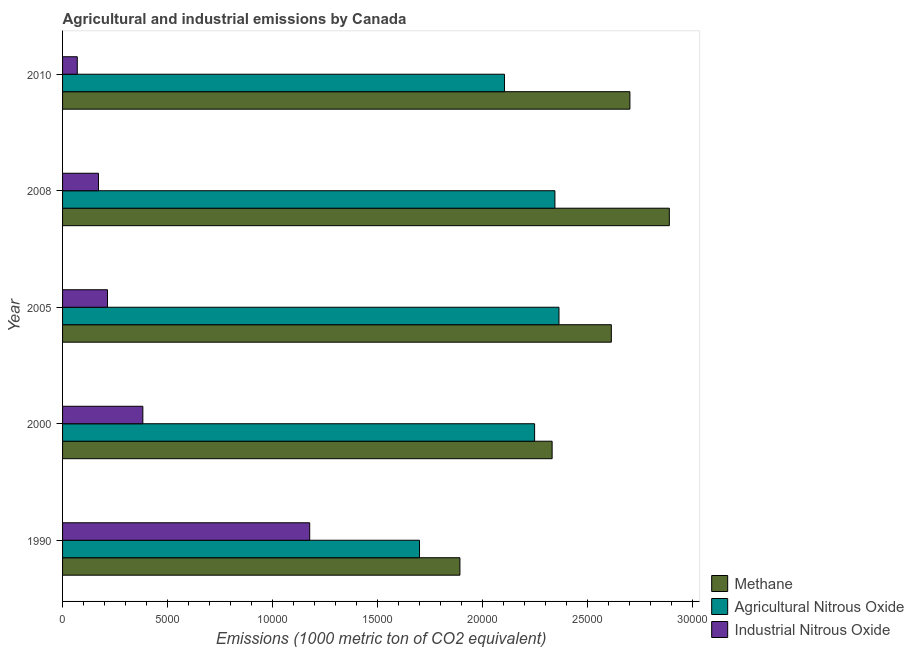How many groups of bars are there?
Your response must be concise. 5. Are the number of bars on each tick of the Y-axis equal?
Your response must be concise. Yes. How many bars are there on the 1st tick from the top?
Your response must be concise. 3. How many bars are there on the 1st tick from the bottom?
Keep it short and to the point. 3. What is the label of the 4th group of bars from the top?
Give a very brief answer. 2000. In how many cases, is the number of bars for a given year not equal to the number of legend labels?
Provide a short and direct response. 0. What is the amount of methane emissions in 2000?
Your answer should be very brief. 2.33e+04. Across all years, what is the maximum amount of industrial nitrous oxide emissions?
Offer a terse response. 1.18e+04. Across all years, what is the minimum amount of methane emissions?
Your answer should be very brief. 1.89e+04. In which year was the amount of industrial nitrous oxide emissions minimum?
Ensure brevity in your answer.  2010. What is the total amount of methane emissions in the graph?
Your response must be concise. 1.24e+05. What is the difference between the amount of agricultural nitrous oxide emissions in 2000 and that in 2010?
Keep it short and to the point. 1435.7. What is the difference between the amount of methane emissions in 2000 and the amount of agricultural nitrous oxide emissions in 1990?
Keep it short and to the point. 6315.8. What is the average amount of industrial nitrous oxide emissions per year?
Keep it short and to the point. 4028.68. In the year 2008, what is the difference between the amount of industrial nitrous oxide emissions and amount of methane emissions?
Make the answer very short. -2.72e+04. What is the ratio of the amount of methane emissions in 2000 to that in 2010?
Ensure brevity in your answer.  0.86. Is the difference between the amount of industrial nitrous oxide emissions in 2000 and 2008 greater than the difference between the amount of methane emissions in 2000 and 2008?
Give a very brief answer. Yes. What is the difference between the highest and the second highest amount of industrial nitrous oxide emissions?
Your answer should be compact. 7946.7. What is the difference between the highest and the lowest amount of methane emissions?
Give a very brief answer. 9973.1. What does the 1st bar from the top in 2010 represents?
Offer a terse response. Industrial Nitrous Oxide. What does the 2nd bar from the bottom in 2010 represents?
Offer a terse response. Agricultural Nitrous Oxide. Is it the case that in every year, the sum of the amount of methane emissions and amount of agricultural nitrous oxide emissions is greater than the amount of industrial nitrous oxide emissions?
Give a very brief answer. Yes. How many years are there in the graph?
Provide a succinct answer. 5. What is the difference between two consecutive major ticks on the X-axis?
Your response must be concise. 5000. Are the values on the major ticks of X-axis written in scientific E-notation?
Keep it short and to the point. No. Where does the legend appear in the graph?
Your response must be concise. Bottom right. How many legend labels are there?
Provide a succinct answer. 3. How are the legend labels stacked?
Your response must be concise. Vertical. What is the title of the graph?
Your response must be concise. Agricultural and industrial emissions by Canada. Does "Nuclear sources" appear as one of the legend labels in the graph?
Keep it short and to the point. No. What is the label or title of the X-axis?
Offer a very short reply. Emissions (1000 metric ton of CO2 equivalent). What is the label or title of the Y-axis?
Provide a succinct answer. Year. What is the Emissions (1000 metric ton of CO2 equivalent) in Methane in 1990?
Make the answer very short. 1.89e+04. What is the Emissions (1000 metric ton of CO2 equivalent) of Agricultural Nitrous Oxide in 1990?
Your answer should be very brief. 1.70e+04. What is the Emissions (1000 metric ton of CO2 equivalent) of Industrial Nitrous Oxide in 1990?
Your answer should be very brief. 1.18e+04. What is the Emissions (1000 metric ton of CO2 equivalent) in Methane in 2000?
Give a very brief answer. 2.33e+04. What is the Emissions (1000 metric ton of CO2 equivalent) in Agricultural Nitrous Oxide in 2000?
Your answer should be very brief. 2.25e+04. What is the Emissions (1000 metric ton of CO2 equivalent) of Industrial Nitrous Oxide in 2000?
Your response must be concise. 3823.3. What is the Emissions (1000 metric ton of CO2 equivalent) in Methane in 2005?
Your answer should be very brief. 2.61e+04. What is the Emissions (1000 metric ton of CO2 equivalent) in Agricultural Nitrous Oxide in 2005?
Provide a succinct answer. 2.36e+04. What is the Emissions (1000 metric ton of CO2 equivalent) of Industrial Nitrous Oxide in 2005?
Ensure brevity in your answer.  2139.7. What is the Emissions (1000 metric ton of CO2 equivalent) of Methane in 2008?
Offer a very short reply. 2.89e+04. What is the Emissions (1000 metric ton of CO2 equivalent) in Agricultural Nitrous Oxide in 2008?
Provide a short and direct response. 2.34e+04. What is the Emissions (1000 metric ton of CO2 equivalent) of Industrial Nitrous Oxide in 2008?
Ensure brevity in your answer.  1709.6. What is the Emissions (1000 metric ton of CO2 equivalent) of Methane in 2010?
Ensure brevity in your answer.  2.70e+04. What is the Emissions (1000 metric ton of CO2 equivalent) of Agricultural Nitrous Oxide in 2010?
Provide a short and direct response. 2.10e+04. What is the Emissions (1000 metric ton of CO2 equivalent) in Industrial Nitrous Oxide in 2010?
Give a very brief answer. 700.8. Across all years, what is the maximum Emissions (1000 metric ton of CO2 equivalent) of Methane?
Your answer should be compact. 2.89e+04. Across all years, what is the maximum Emissions (1000 metric ton of CO2 equivalent) in Agricultural Nitrous Oxide?
Your response must be concise. 2.36e+04. Across all years, what is the maximum Emissions (1000 metric ton of CO2 equivalent) of Industrial Nitrous Oxide?
Provide a short and direct response. 1.18e+04. Across all years, what is the minimum Emissions (1000 metric ton of CO2 equivalent) of Methane?
Keep it short and to the point. 1.89e+04. Across all years, what is the minimum Emissions (1000 metric ton of CO2 equivalent) of Agricultural Nitrous Oxide?
Ensure brevity in your answer.  1.70e+04. Across all years, what is the minimum Emissions (1000 metric ton of CO2 equivalent) of Industrial Nitrous Oxide?
Your response must be concise. 700.8. What is the total Emissions (1000 metric ton of CO2 equivalent) in Methane in the graph?
Give a very brief answer. 1.24e+05. What is the total Emissions (1000 metric ton of CO2 equivalent) in Agricultural Nitrous Oxide in the graph?
Provide a short and direct response. 1.08e+05. What is the total Emissions (1000 metric ton of CO2 equivalent) in Industrial Nitrous Oxide in the graph?
Make the answer very short. 2.01e+04. What is the difference between the Emissions (1000 metric ton of CO2 equivalent) in Methane in 1990 and that in 2000?
Offer a terse response. -4391.7. What is the difference between the Emissions (1000 metric ton of CO2 equivalent) of Agricultural Nitrous Oxide in 1990 and that in 2000?
Your answer should be compact. -5481.4. What is the difference between the Emissions (1000 metric ton of CO2 equivalent) of Industrial Nitrous Oxide in 1990 and that in 2000?
Offer a very short reply. 7946.7. What is the difference between the Emissions (1000 metric ton of CO2 equivalent) of Methane in 1990 and that in 2005?
Ensure brevity in your answer.  -7210.8. What is the difference between the Emissions (1000 metric ton of CO2 equivalent) of Agricultural Nitrous Oxide in 1990 and that in 2005?
Keep it short and to the point. -6642.6. What is the difference between the Emissions (1000 metric ton of CO2 equivalent) in Industrial Nitrous Oxide in 1990 and that in 2005?
Ensure brevity in your answer.  9630.3. What is the difference between the Emissions (1000 metric ton of CO2 equivalent) of Methane in 1990 and that in 2008?
Your response must be concise. -9973.1. What is the difference between the Emissions (1000 metric ton of CO2 equivalent) of Agricultural Nitrous Oxide in 1990 and that in 2008?
Keep it short and to the point. -6448.9. What is the difference between the Emissions (1000 metric ton of CO2 equivalent) of Industrial Nitrous Oxide in 1990 and that in 2008?
Your answer should be very brief. 1.01e+04. What is the difference between the Emissions (1000 metric ton of CO2 equivalent) of Methane in 1990 and that in 2010?
Your answer should be very brief. -8095.8. What is the difference between the Emissions (1000 metric ton of CO2 equivalent) in Agricultural Nitrous Oxide in 1990 and that in 2010?
Ensure brevity in your answer.  -4045.7. What is the difference between the Emissions (1000 metric ton of CO2 equivalent) of Industrial Nitrous Oxide in 1990 and that in 2010?
Make the answer very short. 1.11e+04. What is the difference between the Emissions (1000 metric ton of CO2 equivalent) of Methane in 2000 and that in 2005?
Your answer should be very brief. -2819.1. What is the difference between the Emissions (1000 metric ton of CO2 equivalent) in Agricultural Nitrous Oxide in 2000 and that in 2005?
Keep it short and to the point. -1161.2. What is the difference between the Emissions (1000 metric ton of CO2 equivalent) of Industrial Nitrous Oxide in 2000 and that in 2005?
Give a very brief answer. 1683.6. What is the difference between the Emissions (1000 metric ton of CO2 equivalent) of Methane in 2000 and that in 2008?
Give a very brief answer. -5581.4. What is the difference between the Emissions (1000 metric ton of CO2 equivalent) of Agricultural Nitrous Oxide in 2000 and that in 2008?
Offer a very short reply. -967.5. What is the difference between the Emissions (1000 metric ton of CO2 equivalent) of Industrial Nitrous Oxide in 2000 and that in 2008?
Provide a short and direct response. 2113.7. What is the difference between the Emissions (1000 metric ton of CO2 equivalent) in Methane in 2000 and that in 2010?
Your response must be concise. -3704.1. What is the difference between the Emissions (1000 metric ton of CO2 equivalent) of Agricultural Nitrous Oxide in 2000 and that in 2010?
Make the answer very short. 1435.7. What is the difference between the Emissions (1000 metric ton of CO2 equivalent) in Industrial Nitrous Oxide in 2000 and that in 2010?
Make the answer very short. 3122.5. What is the difference between the Emissions (1000 metric ton of CO2 equivalent) in Methane in 2005 and that in 2008?
Your answer should be very brief. -2762.3. What is the difference between the Emissions (1000 metric ton of CO2 equivalent) of Agricultural Nitrous Oxide in 2005 and that in 2008?
Make the answer very short. 193.7. What is the difference between the Emissions (1000 metric ton of CO2 equivalent) of Industrial Nitrous Oxide in 2005 and that in 2008?
Provide a short and direct response. 430.1. What is the difference between the Emissions (1000 metric ton of CO2 equivalent) in Methane in 2005 and that in 2010?
Your answer should be very brief. -885. What is the difference between the Emissions (1000 metric ton of CO2 equivalent) of Agricultural Nitrous Oxide in 2005 and that in 2010?
Provide a succinct answer. 2596.9. What is the difference between the Emissions (1000 metric ton of CO2 equivalent) of Industrial Nitrous Oxide in 2005 and that in 2010?
Offer a very short reply. 1438.9. What is the difference between the Emissions (1000 metric ton of CO2 equivalent) of Methane in 2008 and that in 2010?
Offer a very short reply. 1877.3. What is the difference between the Emissions (1000 metric ton of CO2 equivalent) of Agricultural Nitrous Oxide in 2008 and that in 2010?
Ensure brevity in your answer.  2403.2. What is the difference between the Emissions (1000 metric ton of CO2 equivalent) in Industrial Nitrous Oxide in 2008 and that in 2010?
Ensure brevity in your answer.  1008.8. What is the difference between the Emissions (1000 metric ton of CO2 equivalent) in Methane in 1990 and the Emissions (1000 metric ton of CO2 equivalent) in Agricultural Nitrous Oxide in 2000?
Ensure brevity in your answer.  -3557.3. What is the difference between the Emissions (1000 metric ton of CO2 equivalent) of Methane in 1990 and the Emissions (1000 metric ton of CO2 equivalent) of Industrial Nitrous Oxide in 2000?
Ensure brevity in your answer.  1.51e+04. What is the difference between the Emissions (1000 metric ton of CO2 equivalent) in Agricultural Nitrous Oxide in 1990 and the Emissions (1000 metric ton of CO2 equivalent) in Industrial Nitrous Oxide in 2000?
Your answer should be compact. 1.32e+04. What is the difference between the Emissions (1000 metric ton of CO2 equivalent) in Methane in 1990 and the Emissions (1000 metric ton of CO2 equivalent) in Agricultural Nitrous Oxide in 2005?
Make the answer very short. -4718.5. What is the difference between the Emissions (1000 metric ton of CO2 equivalent) in Methane in 1990 and the Emissions (1000 metric ton of CO2 equivalent) in Industrial Nitrous Oxide in 2005?
Ensure brevity in your answer.  1.68e+04. What is the difference between the Emissions (1000 metric ton of CO2 equivalent) in Agricultural Nitrous Oxide in 1990 and the Emissions (1000 metric ton of CO2 equivalent) in Industrial Nitrous Oxide in 2005?
Keep it short and to the point. 1.49e+04. What is the difference between the Emissions (1000 metric ton of CO2 equivalent) in Methane in 1990 and the Emissions (1000 metric ton of CO2 equivalent) in Agricultural Nitrous Oxide in 2008?
Provide a short and direct response. -4524.8. What is the difference between the Emissions (1000 metric ton of CO2 equivalent) in Methane in 1990 and the Emissions (1000 metric ton of CO2 equivalent) in Industrial Nitrous Oxide in 2008?
Offer a terse response. 1.72e+04. What is the difference between the Emissions (1000 metric ton of CO2 equivalent) of Agricultural Nitrous Oxide in 1990 and the Emissions (1000 metric ton of CO2 equivalent) of Industrial Nitrous Oxide in 2008?
Make the answer very short. 1.53e+04. What is the difference between the Emissions (1000 metric ton of CO2 equivalent) in Methane in 1990 and the Emissions (1000 metric ton of CO2 equivalent) in Agricultural Nitrous Oxide in 2010?
Ensure brevity in your answer.  -2121.6. What is the difference between the Emissions (1000 metric ton of CO2 equivalent) of Methane in 1990 and the Emissions (1000 metric ton of CO2 equivalent) of Industrial Nitrous Oxide in 2010?
Your answer should be very brief. 1.82e+04. What is the difference between the Emissions (1000 metric ton of CO2 equivalent) in Agricultural Nitrous Oxide in 1990 and the Emissions (1000 metric ton of CO2 equivalent) in Industrial Nitrous Oxide in 2010?
Ensure brevity in your answer.  1.63e+04. What is the difference between the Emissions (1000 metric ton of CO2 equivalent) in Methane in 2000 and the Emissions (1000 metric ton of CO2 equivalent) in Agricultural Nitrous Oxide in 2005?
Your answer should be very brief. -326.8. What is the difference between the Emissions (1000 metric ton of CO2 equivalent) in Methane in 2000 and the Emissions (1000 metric ton of CO2 equivalent) in Industrial Nitrous Oxide in 2005?
Your answer should be very brief. 2.12e+04. What is the difference between the Emissions (1000 metric ton of CO2 equivalent) in Agricultural Nitrous Oxide in 2000 and the Emissions (1000 metric ton of CO2 equivalent) in Industrial Nitrous Oxide in 2005?
Give a very brief answer. 2.03e+04. What is the difference between the Emissions (1000 metric ton of CO2 equivalent) of Methane in 2000 and the Emissions (1000 metric ton of CO2 equivalent) of Agricultural Nitrous Oxide in 2008?
Provide a short and direct response. -133.1. What is the difference between the Emissions (1000 metric ton of CO2 equivalent) in Methane in 2000 and the Emissions (1000 metric ton of CO2 equivalent) in Industrial Nitrous Oxide in 2008?
Make the answer very short. 2.16e+04. What is the difference between the Emissions (1000 metric ton of CO2 equivalent) of Agricultural Nitrous Oxide in 2000 and the Emissions (1000 metric ton of CO2 equivalent) of Industrial Nitrous Oxide in 2008?
Keep it short and to the point. 2.08e+04. What is the difference between the Emissions (1000 metric ton of CO2 equivalent) in Methane in 2000 and the Emissions (1000 metric ton of CO2 equivalent) in Agricultural Nitrous Oxide in 2010?
Offer a terse response. 2270.1. What is the difference between the Emissions (1000 metric ton of CO2 equivalent) of Methane in 2000 and the Emissions (1000 metric ton of CO2 equivalent) of Industrial Nitrous Oxide in 2010?
Provide a short and direct response. 2.26e+04. What is the difference between the Emissions (1000 metric ton of CO2 equivalent) of Agricultural Nitrous Oxide in 2000 and the Emissions (1000 metric ton of CO2 equivalent) of Industrial Nitrous Oxide in 2010?
Your response must be concise. 2.18e+04. What is the difference between the Emissions (1000 metric ton of CO2 equivalent) of Methane in 2005 and the Emissions (1000 metric ton of CO2 equivalent) of Agricultural Nitrous Oxide in 2008?
Make the answer very short. 2686. What is the difference between the Emissions (1000 metric ton of CO2 equivalent) in Methane in 2005 and the Emissions (1000 metric ton of CO2 equivalent) in Industrial Nitrous Oxide in 2008?
Your response must be concise. 2.44e+04. What is the difference between the Emissions (1000 metric ton of CO2 equivalent) of Agricultural Nitrous Oxide in 2005 and the Emissions (1000 metric ton of CO2 equivalent) of Industrial Nitrous Oxide in 2008?
Offer a very short reply. 2.19e+04. What is the difference between the Emissions (1000 metric ton of CO2 equivalent) in Methane in 2005 and the Emissions (1000 metric ton of CO2 equivalent) in Agricultural Nitrous Oxide in 2010?
Offer a terse response. 5089.2. What is the difference between the Emissions (1000 metric ton of CO2 equivalent) in Methane in 2005 and the Emissions (1000 metric ton of CO2 equivalent) in Industrial Nitrous Oxide in 2010?
Offer a very short reply. 2.54e+04. What is the difference between the Emissions (1000 metric ton of CO2 equivalent) of Agricultural Nitrous Oxide in 2005 and the Emissions (1000 metric ton of CO2 equivalent) of Industrial Nitrous Oxide in 2010?
Offer a terse response. 2.29e+04. What is the difference between the Emissions (1000 metric ton of CO2 equivalent) in Methane in 2008 and the Emissions (1000 metric ton of CO2 equivalent) in Agricultural Nitrous Oxide in 2010?
Offer a very short reply. 7851.5. What is the difference between the Emissions (1000 metric ton of CO2 equivalent) in Methane in 2008 and the Emissions (1000 metric ton of CO2 equivalent) in Industrial Nitrous Oxide in 2010?
Keep it short and to the point. 2.82e+04. What is the difference between the Emissions (1000 metric ton of CO2 equivalent) of Agricultural Nitrous Oxide in 2008 and the Emissions (1000 metric ton of CO2 equivalent) of Industrial Nitrous Oxide in 2010?
Offer a very short reply. 2.27e+04. What is the average Emissions (1000 metric ton of CO2 equivalent) of Methane per year?
Offer a terse response. 2.49e+04. What is the average Emissions (1000 metric ton of CO2 equivalent) in Agricultural Nitrous Oxide per year?
Your answer should be very brief. 2.15e+04. What is the average Emissions (1000 metric ton of CO2 equivalent) in Industrial Nitrous Oxide per year?
Offer a very short reply. 4028.68. In the year 1990, what is the difference between the Emissions (1000 metric ton of CO2 equivalent) of Methane and Emissions (1000 metric ton of CO2 equivalent) of Agricultural Nitrous Oxide?
Your answer should be very brief. 1924.1. In the year 1990, what is the difference between the Emissions (1000 metric ton of CO2 equivalent) of Methane and Emissions (1000 metric ton of CO2 equivalent) of Industrial Nitrous Oxide?
Offer a terse response. 7153.5. In the year 1990, what is the difference between the Emissions (1000 metric ton of CO2 equivalent) in Agricultural Nitrous Oxide and Emissions (1000 metric ton of CO2 equivalent) in Industrial Nitrous Oxide?
Your answer should be very brief. 5229.4. In the year 2000, what is the difference between the Emissions (1000 metric ton of CO2 equivalent) of Methane and Emissions (1000 metric ton of CO2 equivalent) of Agricultural Nitrous Oxide?
Give a very brief answer. 834.4. In the year 2000, what is the difference between the Emissions (1000 metric ton of CO2 equivalent) of Methane and Emissions (1000 metric ton of CO2 equivalent) of Industrial Nitrous Oxide?
Provide a short and direct response. 1.95e+04. In the year 2000, what is the difference between the Emissions (1000 metric ton of CO2 equivalent) in Agricultural Nitrous Oxide and Emissions (1000 metric ton of CO2 equivalent) in Industrial Nitrous Oxide?
Give a very brief answer. 1.87e+04. In the year 2005, what is the difference between the Emissions (1000 metric ton of CO2 equivalent) of Methane and Emissions (1000 metric ton of CO2 equivalent) of Agricultural Nitrous Oxide?
Offer a very short reply. 2492.3. In the year 2005, what is the difference between the Emissions (1000 metric ton of CO2 equivalent) of Methane and Emissions (1000 metric ton of CO2 equivalent) of Industrial Nitrous Oxide?
Ensure brevity in your answer.  2.40e+04. In the year 2005, what is the difference between the Emissions (1000 metric ton of CO2 equivalent) of Agricultural Nitrous Oxide and Emissions (1000 metric ton of CO2 equivalent) of Industrial Nitrous Oxide?
Your answer should be compact. 2.15e+04. In the year 2008, what is the difference between the Emissions (1000 metric ton of CO2 equivalent) of Methane and Emissions (1000 metric ton of CO2 equivalent) of Agricultural Nitrous Oxide?
Your answer should be compact. 5448.3. In the year 2008, what is the difference between the Emissions (1000 metric ton of CO2 equivalent) of Methane and Emissions (1000 metric ton of CO2 equivalent) of Industrial Nitrous Oxide?
Offer a terse response. 2.72e+04. In the year 2008, what is the difference between the Emissions (1000 metric ton of CO2 equivalent) of Agricultural Nitrous Oxide and Emissions (1000 metric ton of CO2 equivalent) of Industrial Nitrous Oxide?
Your answer should be compact. 2.17e+04. In the year 2010, what is the difference between the Emissions (1000 metric ton of CO2 equivalent) in Methane and Emissions (1000 metric ton of CO2 equivalent) in Agricultural Nitrous Oxide?
Keep it short and to the point. 5974.2. In the year 2010, what is the difference between the Emissions (1000 metric ton of CO2 equivalent) in Methane and Emissions (1000 metric ton of CO2 equivalent) in Industrial Nitrous Oxide?
Your answer should be compact. 2.63e+04. In the year 2010, what is the difference between the Emissions (1000 metric ton of CO2 equivalent) in Agricultural Nitrous Oxide and Emissions (1000 metric ton of CO2 equivalent) in Industrial Nitrous Oxide?
Your answer should be very brief. 2.03e+04. What is the ratio of the Emissions (1000 metric ton of CO2 equivalent) of Methane in 1990 to that in 2000?
Your answer should be very brief. 0.81. What is the ratio of the Emissions (1000 metric ton of CO2 equivalent) of Agricultural Nitrous Oxide in 1990 to that in 2000?
Offer a very short reply. 0.76. What is the ratio of the Emissions (1000 metric ton of CO2 equivalent) of Industrial Nitrous Oxide in 1990 to that in 2000?
Offer a terse response. 3.08. What is the ratio of the Emissions (1000 metric ton of CO2 equivalent) in Methane in 1990 to that in 2005?
Offer a very short reply. 0.72. What is the ratio of the Emissions (1000 metric ton of CO2 equivalent) in Agricultural Nitrous Oxide in 1990 to that in 2005?
Offer a terse response. 0.72. What is the ratio of the Emissions (1000 metric ton of CO2 equivalent) in Industrial Nitrous Oxide in 1990 to that in 2005?
Give a very brief answer. 5.5. What is the ratio of the Emissions (1000 metric ton of CO2 equivalent) of Methane in 1990 to that in 2008?
Give a very brief answer. 0.65. What is the ratio of the Emissions (1000 metric ton of CO2 equivalent) of Agricultural Nitrous Oxide in 1990 to that in 2008?
Provide a short and direct response. 0.72. What is the ratio of the Emissions (1000 metric ton of CO2 equivalent) in Industrial Nitrous Oxide in 1990 to that in 2008?
Offer a very short reply. 6.88. What is the ratio of the Emissions (1000 metric ton of CO2 equivalent) in Methane in 1990 to that in 2010?
Give a very brief answer. 0.7. What is the ratio of the Emissions (1000 metric ton of CO2 equivalent) of Agricultural Nitrous Oxide in 1990 to that in 2010?
Your answer should be very brief. 0.81. What is the ratio of the Emissions (1000 metric ton of CO2 equivalent) in Industrial Nitrous Oxide in 1990 to that in 2010?
Keep it short and to the point. 16.8. What is the ratio of the Emissions (1000 metric ton of CO2 equivalent) of Methane in 2000 to that in 2005?
Give a very brief answer. 0.89. What is the ratio of the Emissions (1000 metric ton of CO2 equivalent) of Agricultural Nitrous Oxide in 2000 to that in 2005?
Give a very brief answer. 0.95. What is the ratio of the Emissions (1000 metric ton of CO2 equivalent) in Industrial Nitrous Oxide in 2000 to that in 2005?
Your answer should be very brief. 1.79. What is the ratio of the Emissions (1000 metric ton of CO2 equivalent) in Methane in 2000 to that in 2008?
Offer a very short reply. 0.81. What is the ratio of the Emissions (1000 metric ton of CO2 equivalent) in Agricultural Nitrous Oxide in 2000 to that in 2008?
Ensure brevity in your answer.  0.96. What is the ratio of the Emissions (1000 metric ton of CO2 equivalent) in Industrial Nitrous Oxide in 2000 to that in 2008?
Offer a terse response. 2.24. What is the ratio of the Emissions (1000 metric ton of CO2 equivalent) in Methane in 2000 to that in 2010?
Ensure brevity in your answer.  0.86. What is the ratio of the Emissions (1000 metric ton of CO2 equivalent) in Agricultural Nitrous Oxide in 2000 to that in 2010?
Your answer should be compact. 1.07. What is the ratio of the Emissions (1000 metric ton of CO2 equivalent) in Industrial Nitrous Oxide in 2000 to that in 2010?
Keep it short and to the point. 5.46. What is the ratio of the Emissions (1000 metric ton of CO2 equivalent) of Methane in 2005 to that in 2008?
Offer a very short reply. 0.9. What is the ratio of the Emissions (1000 metric ton of CO2 equivalent) of Agricultural Nitrous Oxide in 2005 to that in 2008?
Ensure brevity in your answer.  1.01. What is the ratio of the Emissions (1000 metric ton of CO2 equivalent) in Industrial Nitrous Oxide in 2005 to that in 2008?
Give a very brief answer. 1.25. What is the ratio of the Emissions (1000 metric ton of CO2 equivalent) of Methane in 2005 to that in 2010?
Offer a very short reply. 0.97. What is the ratio of the Emissions (1000 metric ton of CO2 equivalent) in Agricultural Nitrous Oxide in 2005 to that in 2010?
Provide a short and direct response. 1.12. What is the ratio of the Emissions (1000 metric ton of CO2 equivalent) of Industrial Nitrous Oxide in 2005 to that in 2010?
Your answer should be very brief. 3.05. What is the ratio of the Emissions (1000 metric ton of CO2 equivalent) in Methane in 2008 to that in 2010?
Give a very brief answer. 1.07. What is the ratio of the Emissions (1000 metric ton of CO2 equivalent) in Agricultural Nitrous Oxide in 2008 to that in 2010?
Offer a very short reply. 1.11. What is the ratio of the Emissions (1000 metric ton of CO2 equivalent) in Industrial Nitrous Oxide in 2008 to that in 2010?
Provide a short and direct response. 2.44. What is the difference between the highest and the second highest Emissions (1000 metric ton of CO2 equivalent) in Methane?
Your response must be concise. 1877.3. What is the difference between the highest and the second highest Emissions (1000 metric ton of CO2 equivalent) in Agricultural Nitrous Oxide?
Keep it short and to the point. 193.7. What is the difference between the highest and the second highest Emissions (1000 metric ton of CO2 equivalent) of Industrial Nitrous Oxide?
Your response must be concise. 7946.7. What is the difference between the highest and the lowest Emissions (1000 metric ton of CO2 equivalent) of Methane?
Provide a succinct answer. 9973.1. What is the difference between the highest and the lowest Emissions (1000 metric ton of CO2 equivalent) of Agricultural Nitrous Oxide?
Your answer should be compact. 6642.6. What is the difference between the highest and the lowest Emissions (1000 metric ton of CO2 equivalent) in Industrial Nitrous Oxide?
Your answer should be compact. 1.11e+04. 